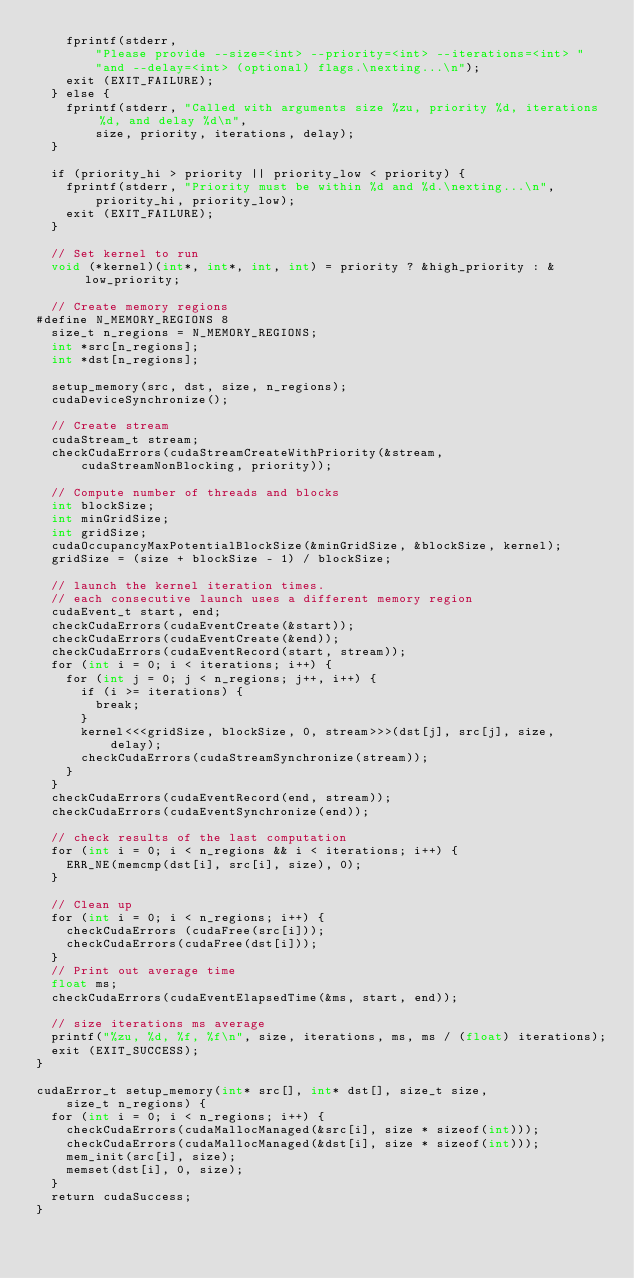<code> <loc_0><loc_0><loc_500><loc_500><_Cuda_>    fprintf(stderr,
        "Please provide --size=<int> --priority=<int> --iterations=<int> "
        "and --delay=<int> (optional) flags.\nexting...\n");
    exit (EXIT_FAILURE);
  } else {
    fprintf(stderr, "Called with arguments size %zu, priority %d, iterations %d, and delay %d\n",
        size, priority, iterations, delay);
  }
  
  if (priority_hi > priority || priority_low < priority) {
    fprintf(stderr, "Priority must be within %d and %d.\nexting...\n",
        priority_hi, priority_low);
    exit (EXIT_FAILURE);
  }

  // Set kernel to run
  void (*kernel)(int*, int*, int, int) = priority ? &high_priority : &low_priority;
  
  // Create memory regions
#define N_MEMORY_REGIONS 8
  size_t n_regions = N_MEMORY_REGIONS;
  int *src[n_regions];
  int *dst[n_regions];
  
  setup_memory(src, dst, size, n_regions);
  cudaDeviceSynchronize();

  // Create stream
  cudaStream_t stream;
  checkCudaErrors(cudaStreamCreateWithPriority(&stream,
      cudaStreamNonBlocking, priority));
 
  // Compute number of threads and blocks
  int blockSize;
  int minGridSize;
  int gridSize;
  cudaOccupancyMaxPotentialBlockSize(&minGridSize, &blockSize, kernel);
  gridSize = (size + blockSize - 1) / blockSize;
 
  // launch the kernel iteration times.
  // each consecutive launch uses a different memory region
  cudaEvent_t start, end;
  checkCudaErrors(cudaEventCreate(&start));
  checkCudaErrors(cudaEventCreate(&end));
  checkCudaErrors(cudaEventRecord(start, stream));
  for (int i = 0; i < iterations; i++) {
    for (int j = 0; j < n_regions; j++, i++) {
      if (i >= iterations) {
        break;
      }
      kernel<<<gridSize, blockSize, 0, stream>>>(dst[j], src[j], size,
          delay);
      checkCudaErrors(cudaStreamSynchronize(stream));
    }
  }
  checkCudaErrors(cudaEventRecord(end, stream));
  checkCudaErrors(cudaEventSynchronize(end));

  // check results of the last computation
  for (int i = 0; i < n_regions && i < iterations; i++) {
    ERR_NE(memcmp(dst[i], src[i], size), 0);  
  }
  
  // Clean up
  for (int i = 0; i < n_regions; i++) {
    checkCudaErrors (cudaFree(src[i]));
    checkCudaErrors(cudaFree(dst[i]));
  }
  // Print out average time
  float ms;
  checkCudaErrors(cudaEventElapsedTime(&ms, start, end));

  // size iterations ms average
  printf("%zu, %d, %f, %f\n", size, iterations, ms, ms / (float) iterations);
  exit (EXIT_SUCCESS);
}

cudaError_t setup_memory(int* src[], int* dst[], size_t size,
    size_t n_regions) {
  for (int i = 0; i < n_regions; i++) {
    checkCudaErrors(cudaMallocManaged(&src[i], size * sizeof(int)));
    checkCudaErrors(cudaMallocManaged(&dst[i], size * sizeof(int)));
    mem_init(src[i], size);
    memset(dst[i], 0, size);
  }
  return cudaSuccess;
}

</code> 